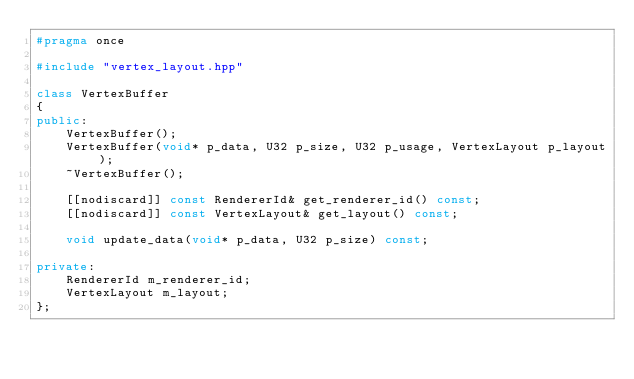Convert code to text. <code><loc_0><loc_0><loc_500><loc_500><_C++_>#pragma once

#include "vertex_layout.hpp"

class VertexBuffer
{
public:
    VertexBuffer();
    VertexBuffer(void* p_data, U32 p_size, U32 p_usage, VertexLayout p_layout);
    ~VertexBuffer();

    [[nodiscard]] const RendererId& get_renderer_id() const;
    [[nodiscard]] const VertexLayout& get_layout() const;

    void update_data(void* p_data, U32 p_size) const;

private:
    RendererId m_renderer_id;
    VertexLayout m_layout;
};
</code> 